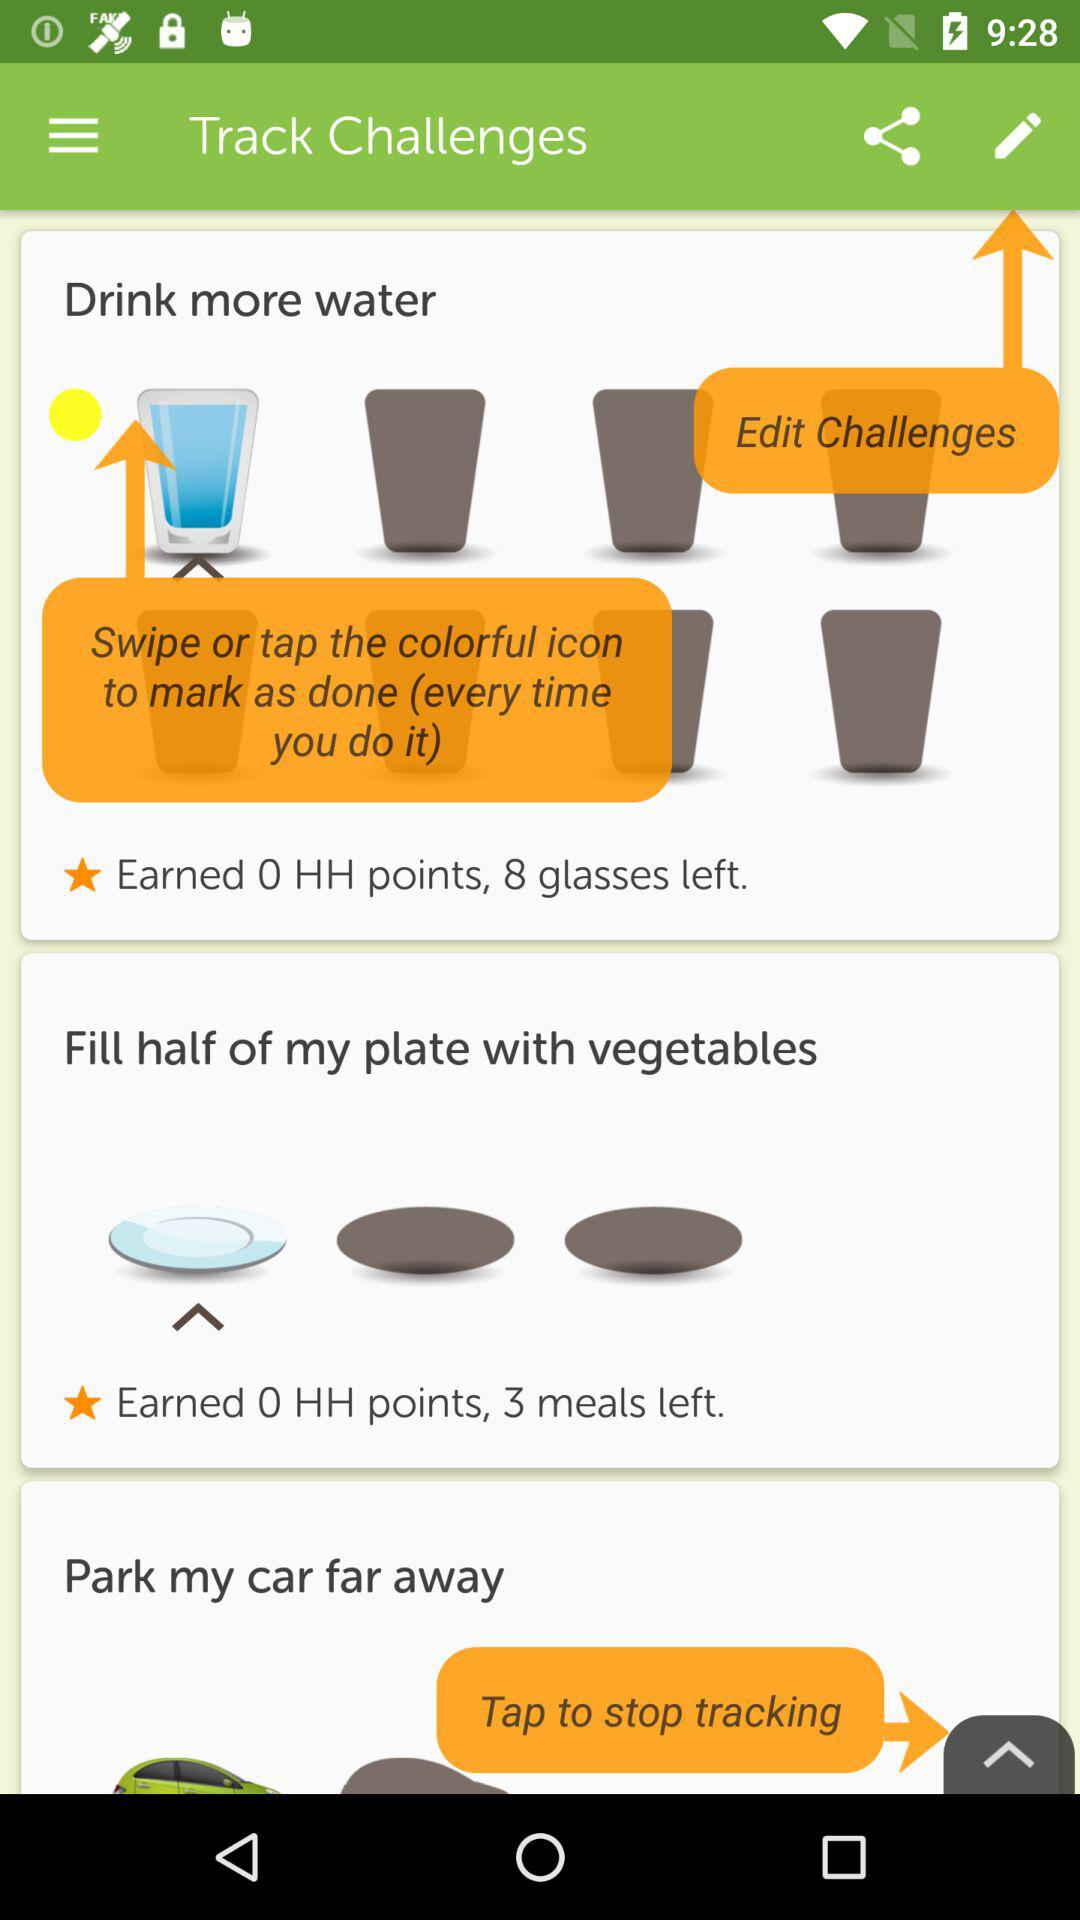How many challenges are there?
Answer the question using a single word or phrase. 3 